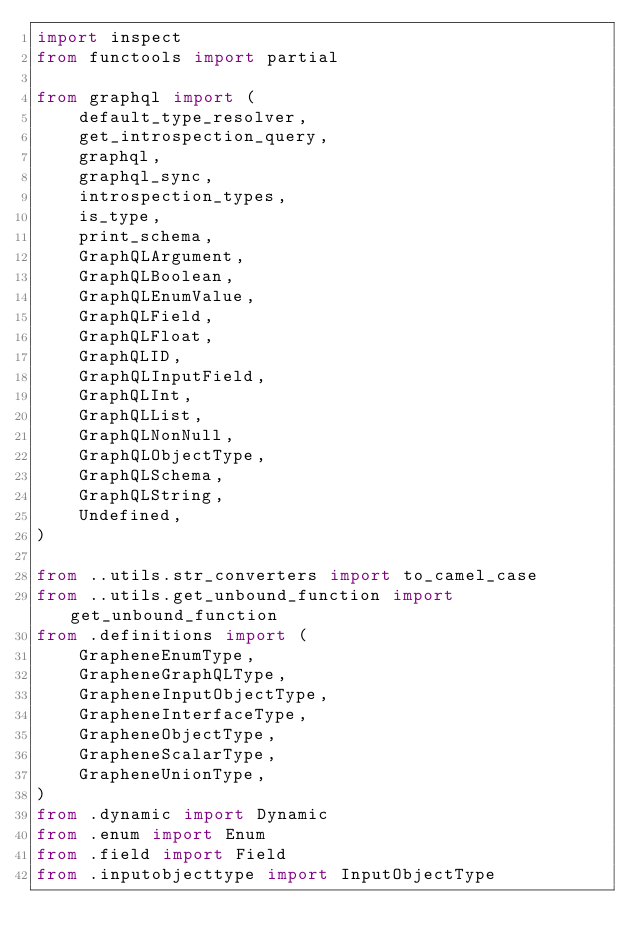Convert code to text. <code><loc_0><loc_0><loc_500><loc_500><_Python_>import inspect
from functools import partial

from graphql import (
    default_type_resolver,
    get_introspection_query,
    graphql,
    graphql_sync,
    introspection_types,
    is_type,
    print_schema,
    GraphQLArgument,
    GraphQLBoolean,
    GraphQLEnumValue,
    GraphQLField,
    GraphQLFloat,
    GraphQLID,
    GraphQLInputField,
    GraphQLInt,
    GraphQLList,
    GraphQLNonNull,
    GraphQLObjectType,
    GraphQLSchema,
    GraphQLString,
    Undefined,
)

from ..utils.str_converters import to_camel_case
from ..utils.get_unbound_function import get_unbound_function
from .definitions import (
    GrapheneEnumType,
    GrapheneGraphQLType,
    GrapheneInputObjectType,
    GrapheneInterfaceType,
    GrapheneObjectType,
    GrapheneScalarType,
    GrapheneUnionType,
)
from .dynamic import Dynamic
from .enum import Enum
from .field import Field
from .inputobjecttype import InputObjectType</code> 